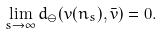<formula> <loc_0><loc_0><loc_500><loc_500>\lim _ { s \to \infty } d _ { \ominus } ( v ( n _ { s } ) , \bar { v } ) = 0 .</formula> 